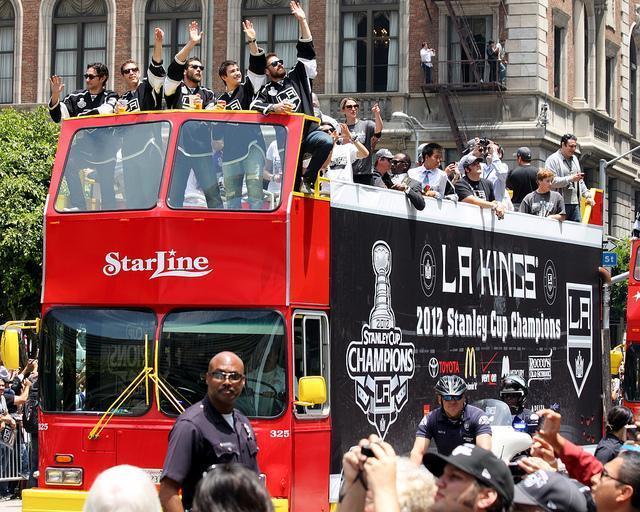How many people are in the picture?
Give a very brief answer. 10. How many buses are in the picture?
Give a very brief answer. 1. How many clock faces are shown?
Give a very brief answer. 0. 